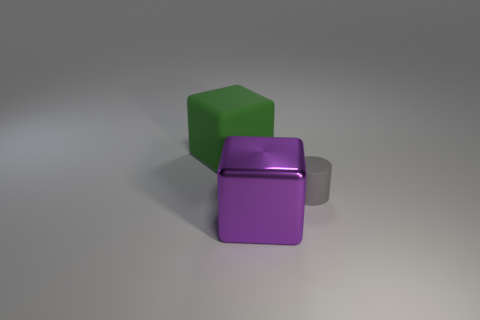What is the material of the big green block?
Offer a very short reply. Rubber. Does the large cube on the left side of the big purple cube have the same material as the cube that is on the right side of the large green rubber cube?
Keep it short and to the point. No. What color is the metal thing that is the same shape as the green matte object?
Your answer should be compact. Purple. There is a thing that is behind the purple object and in front of the large green matte thing; how big is it?
Ensure brevity in your answer.  Small. There is a rubber thing behind the tiny gray matte object; does it have the same shape as the matte object that is right of the big rubber thing?
Offer a terse response. No. What number of other green objects have the same material as the small thing?
Keep it short and to the point. 1. There is a object that is behind the purple shiny cube and in front of the green rubber thing; what shape is it?
Ensure brevity in your answer.  Cylinder. Is the block that is right of the rubber cube made of the same material as the gray object?
Provide a succinct answer. No. Is there any other thing that has the same material as the purple block?
Your response must be concise. No. There is a cube that is the same size as the green rubber thing; what is its color?
Your response must be concise. Purple. 